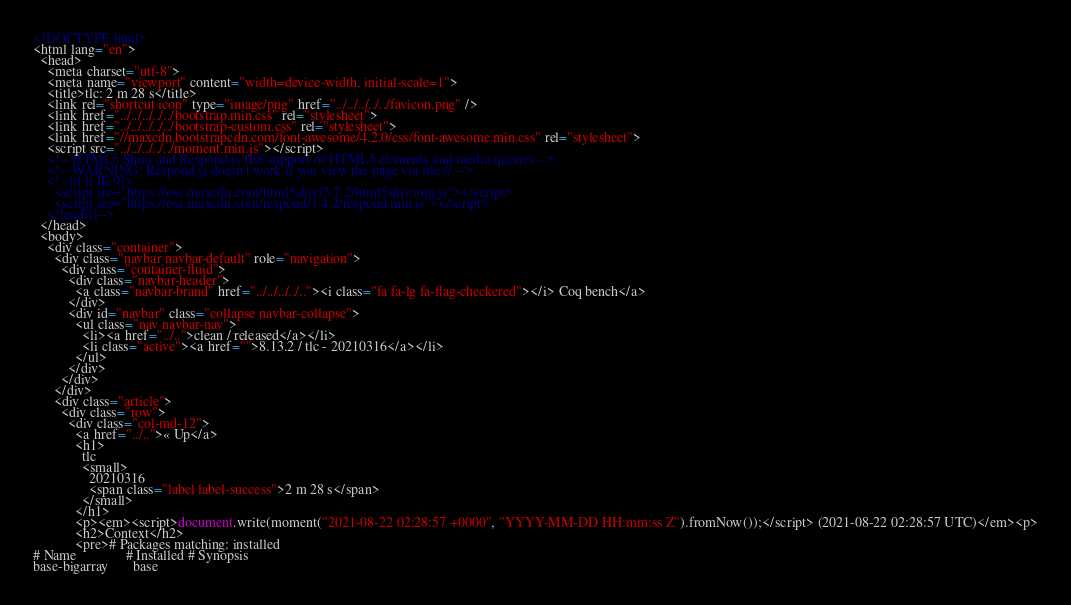<code> <loc_0><loc_0><loc_500><loc_500><_HTML_><!DOCTYPE html>
<html lang="en">
  <head>
    <meta charset="utf-8">
    <meta name="viewport" content="width=device-width, initial-scale=1">
    <title>tlc: 2 m 28 s</title>
    <link rel="shortcut icon" type="image/png" href="../../../../../favicon.png" />
    <link href="../../../../../bootstrap.min.css" rel="stylesheet">
    <link href="../../../../../bootstrap-custom.css" rel="stylesheet">
    <link href="//maxcdn.bootstrapcdn.com/font-awesome/4.2.0/css/font-awesome.min.css" rel="stylesheet">
    <script src="../../../../../moment.min.js"></script>
    <!-- HTML5 Shim and Respond.js IE8 support of HTML5 elements and media queries -->
    <!-- WARNING: Respond.js doesn't work if you view the page via file:// -->
    <!--[if lt IE 9]>
      <script src="https://oss.maxcdn.com/html5shiv/3.7.2/html5shiv.min.js"></script>
      <script src="https://oss.maxcdn.com/respond/1.4.2/respond.min.js"></script>
    <![endif]-->
  </head>
  <body>
    <div class="container">
      <div class="navbar navbar-default" role="navigation">
        <div class="container-fluid">
          <div class="navbar-header">
            <a class="navbar-brand" href="../../../../.."><i class="fa fa-lg fa-flag-checkered"></i> Coq bench</a>
          </div>
          <div id="navbar" class="collapse navbar-collapse">
            <ul class="nav navbar-nav">
              <li><a href="../..">clean / released</a></li>
              <li class="active"><a href="">8.13.2 / tlc - 20210316</a></li>
            </ul>
          </div>
        </div>
      </div>
      <div class="article">
        <div class="row">
          <div class="col-md-12">
            <a href="../..">« Up</a>
            <h1>
              tlc
              <small>
                20210316
                <span class="label label-success">2 m 28 s</span>
              </small>
            </h1>
            <p><em><script>document.write(moment("2021-08-22 02:28:57 +0000", "YYYY-MM-DD HH:mm:ss Z").fromNow());</script> (2021-08-22 02:28:57 UTC)</em><p>
            <h2>Context</h2>
            <pre># Packages matching: installed
# Name              # Installed # Synopsis
base-bigarray       base</code> 